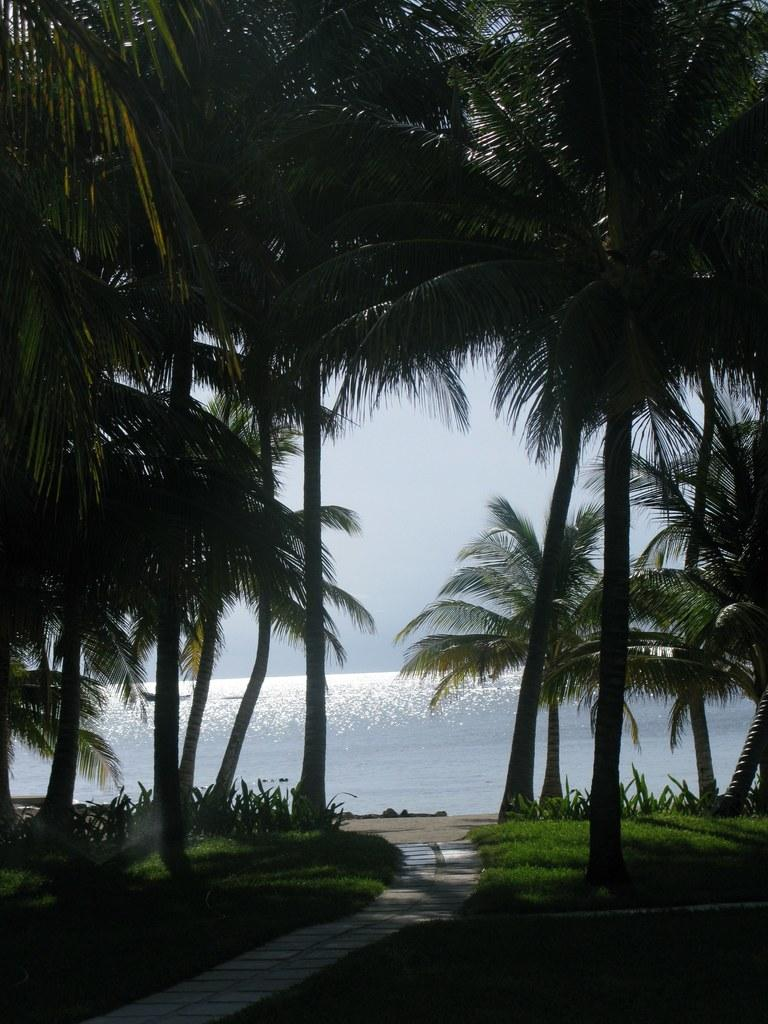What type of vegetation can be seen in the image? There is grass, plants, and trees visible in the image. Is there any indication of a path or walkway in the image? Yes, there is a path in the image. What can be seen in the background of the image? Water and the sky are visible in the background of the image. What type of headwear is being worn by the tree in the image? There are no trees wearing headwear in the image, as trees do not wear clothing or accessories. 